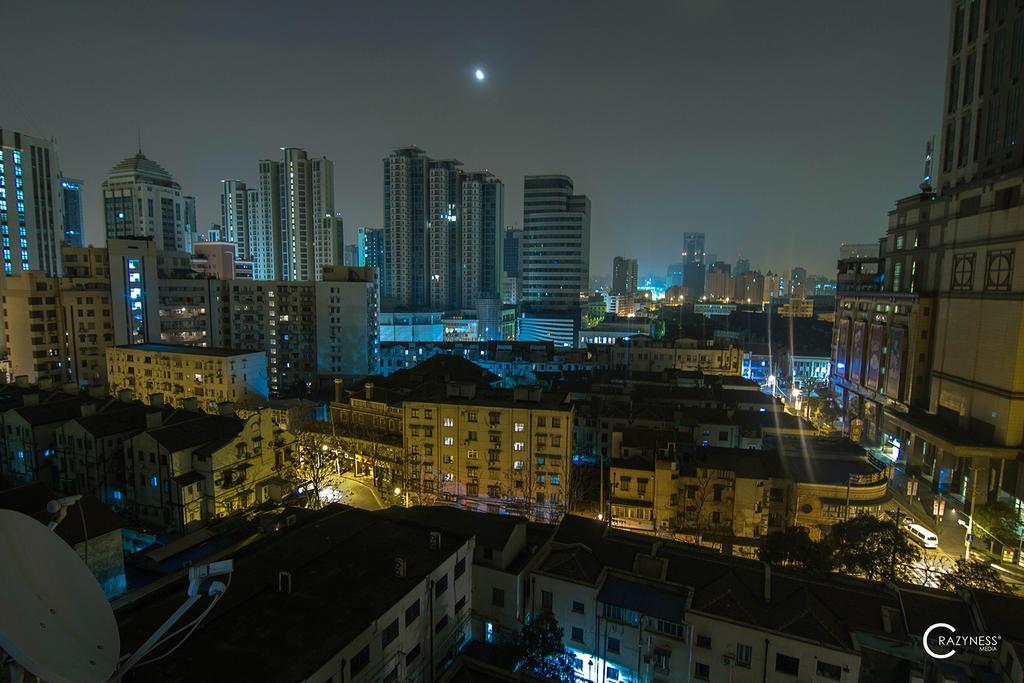Please provide a concise description of this image. In this picture we can see few buildings, lights, poles, trees and hoardings, in the bottom right hand corner we can see some text. 